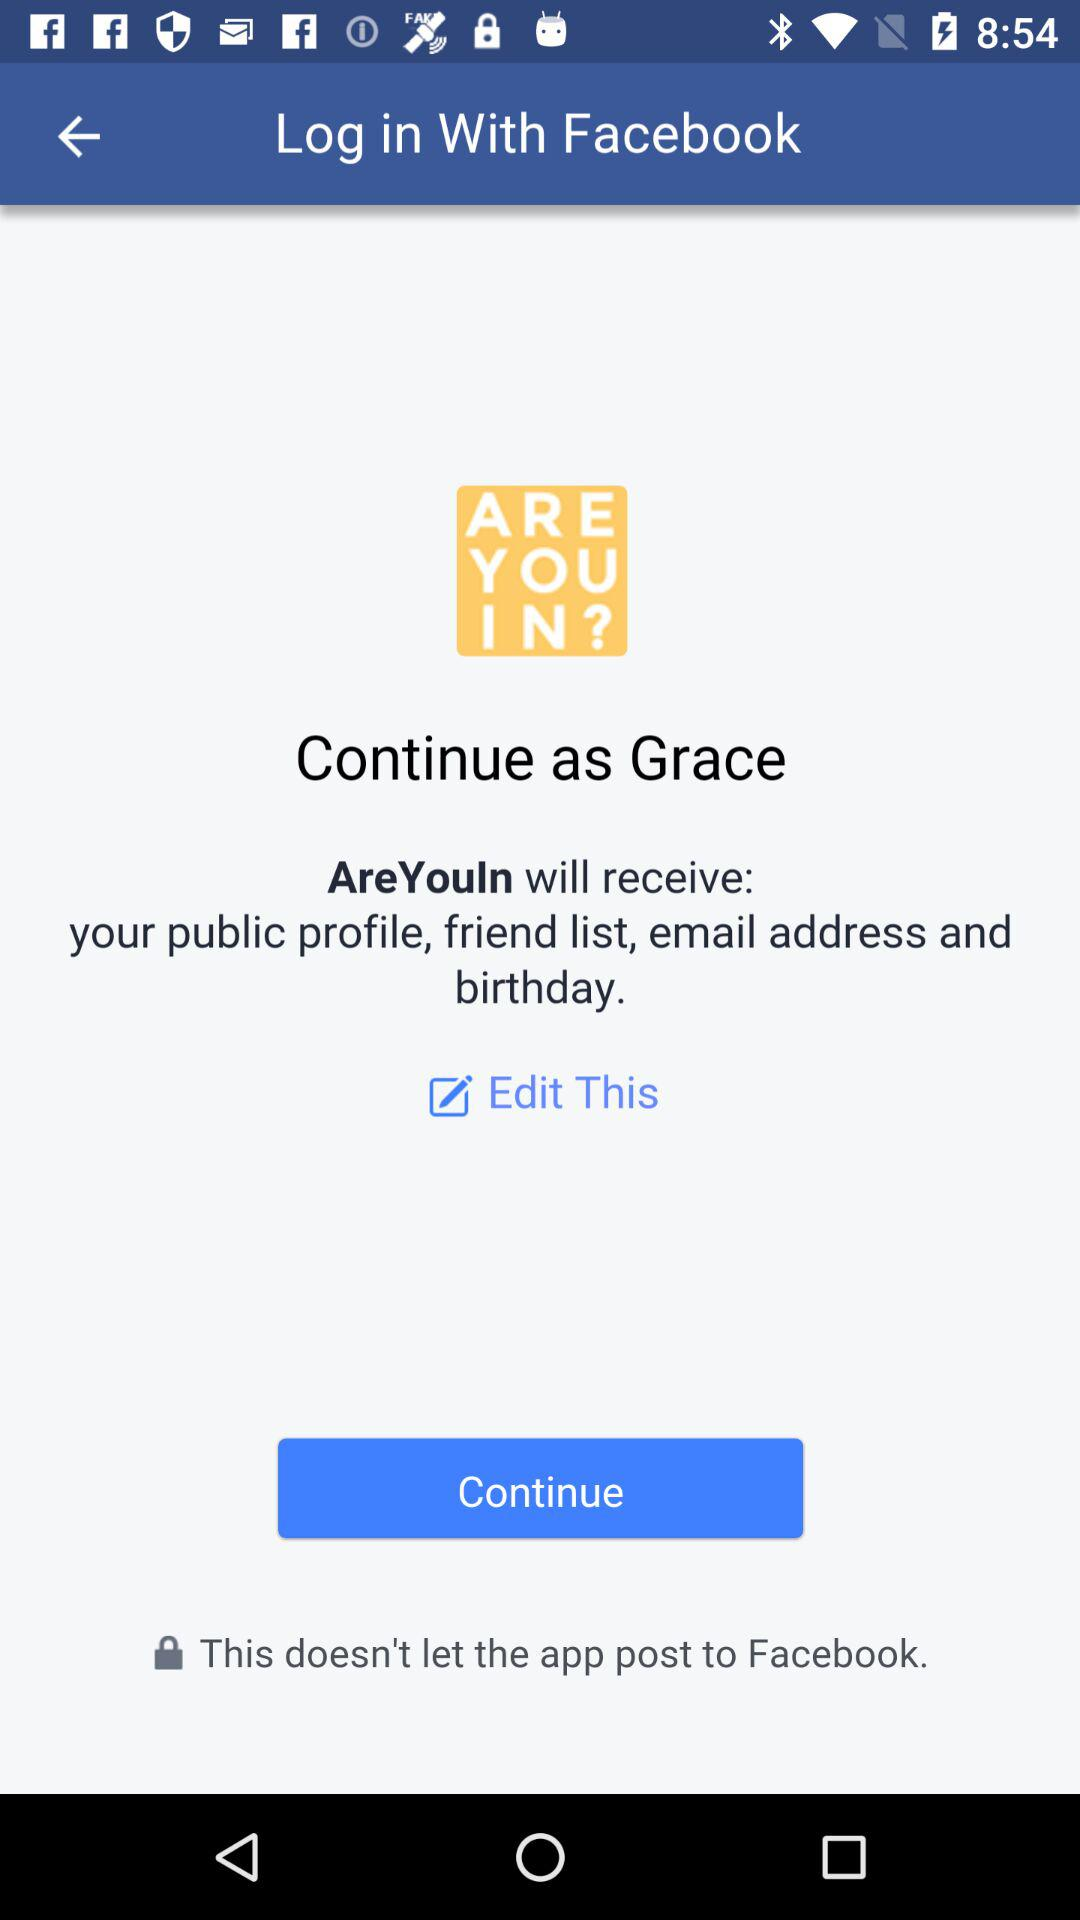What application is asking for permission? The application is "AreYouIn". 